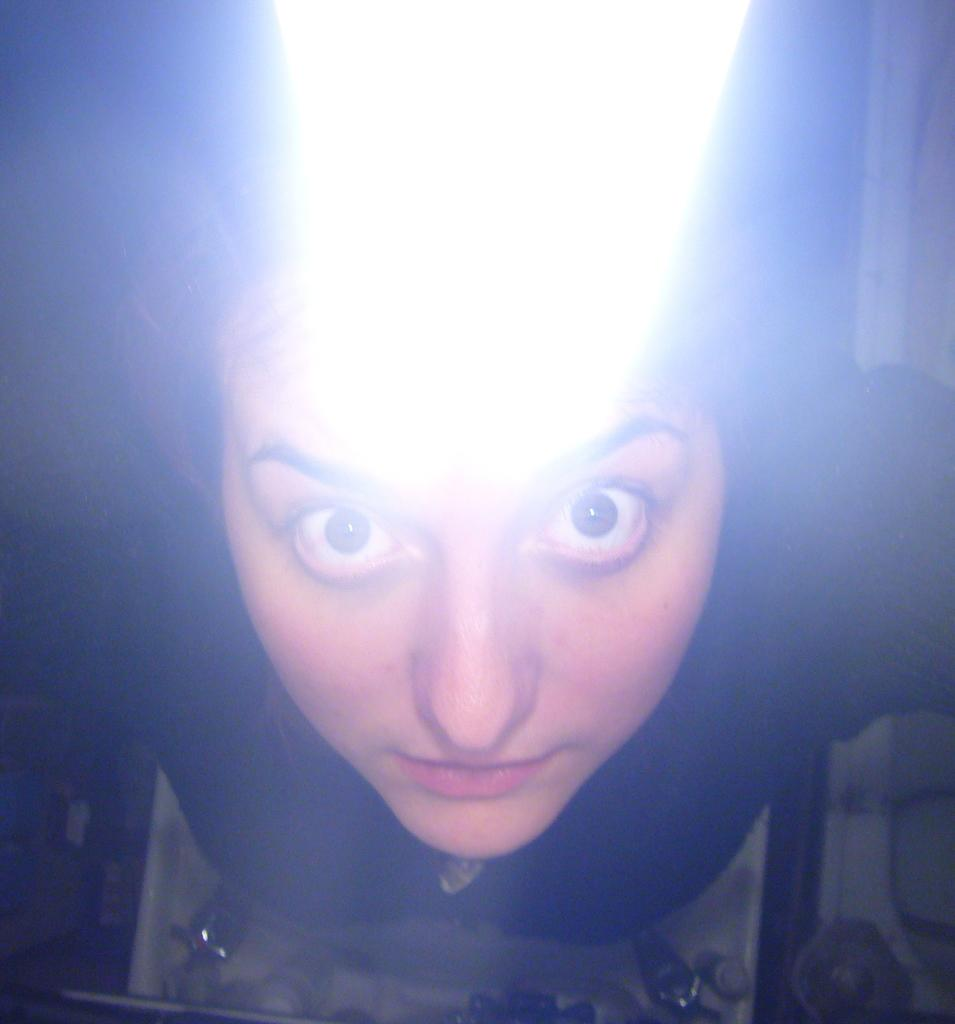What is the main subject of the image? The main subject of the image is a person. What is the person wearing in the image? The person is wearing a black dress. What object can be seen in the foreground of the image? There is a tap in the foreground of the image. What type of road can be seen in the image? There is no road present in the image. What scientific discovery is being made in the image? There is no scientific discovery being made in the image. 